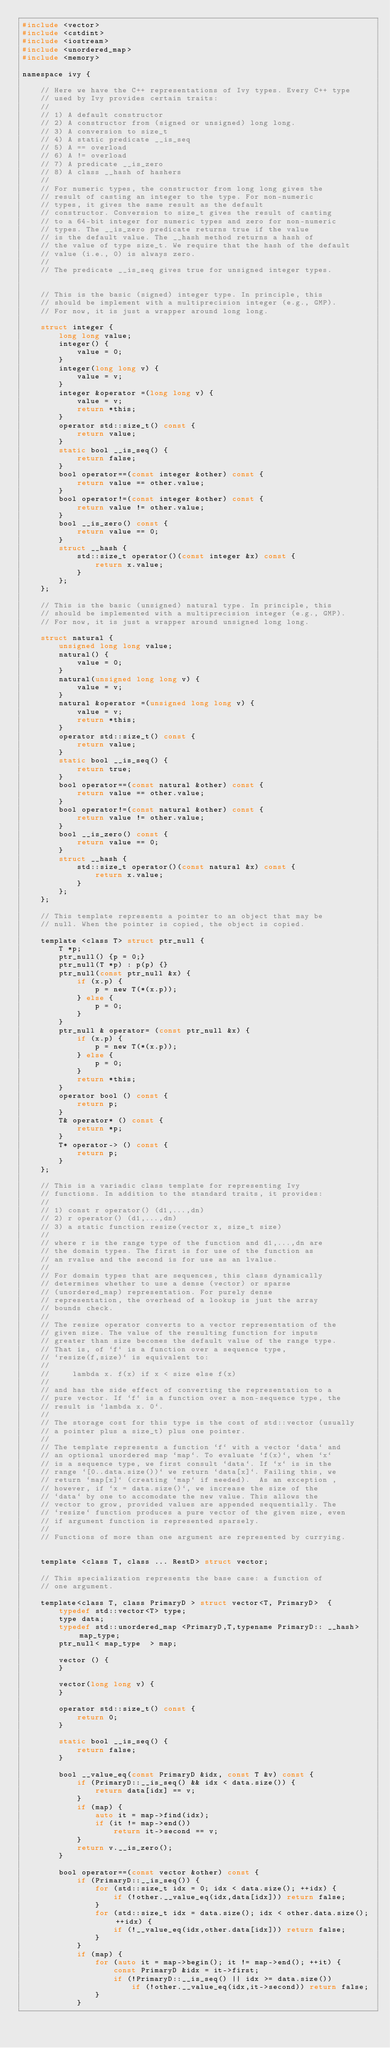<code> <loc_0><loc_0><loc_500><loc_500><_C_>#include <vector>
#include <cstdint>
#include <iostream>
#include <unordered_map>
#include <memory>

namespace ivy {

    // Here we have the C++ representations of Ivy types. Every C++ type
    // used by Ivy provides certain traits:
    //
    // 1) A default constructor
    // 2) A constructor from (signed or unsigned) long long.
    // 3) A conversion to size_t
    // 4) A static predicate __is_seq
    // 5) A == overload
    // 6) A != overload
    // 7) A predicate __is_zero
    // 8) A class __hash of hashers
    //
    // For numeric types, the constructor from long long gives the
    // result of casting an integer to the type. For non-numeric
    // types, it gives the same result as the default
    // constructor. Conversion to size_t gives the result of casting
    // to a 64-bit integer for numeric types and zero for non-numeric
    // types. The __is_zero predicate returns true if the value
    // is the default value. The __hash method returns a hash of
    // the value of type size_t. We require that the hash of the default
    // value (i.e., 0) is always zero.
    // 
    // The predicate __is_seq gives true for unsigned integer types.
    

    // This is the basic (signed) integer type. In principle, this
    // should be implement with a multiprecision integer (e.g., GMP).
    // For now, it is just a wrapper around long long.

    struct integer {
        long long value;
        integer() {
            value = 0;
        }
        integer(long long v) {
            value = v;
        }
        integer &operator =(long long v) {
            value = v;
            return *this;
        }
        operator std::size_t() const {
            return value;
        }
        static bool __is_seq() {
            return false;
        }
        bool operator==(const integer &other) const {
            return value == other.value;
        }
        bool operator!=(const integer &other) const {
            return value != other.value;
        }
        bool __is_zero() const {
            return value == 0;
        }
        struct __hash {
            std::size_t operator()(const integer &x) const {
                return x.value;
            }
        };
    };

    // This is the basic (unsigned) natural type. In principle, this
    // should be implemented with a multiprecision integer (e.g., GMP).
    // For now, it is just a wrapper around unsigned long long.

    struct natural {
        unsigned long long value;
        natural() {
            value = 0;
        }
        natural(unsigned long long v) {
            value = v;
        }
        natural &operator =(unsigned long long v) {
            value = v;
            return *this;
        }
        operator std::size_t() const {
            return value;
        }
        static bool __is_seq() {
            return true;
        }
        bool operator==(const natural &other) const {
            return value == other.value;
        }
        bool operator!=(const natural &other) const {
            return value != other.value;
        }
        bool __is_zero() const {
            return value == 0;
        }
        struct __hash {
            std::size_t operator()(const natural &x) const {
                return x.value;
            }
        };
    };

    // This template represents a pointer to an object that may be
    // null. When the pointer is copied, the object is copied.

    template <class T> struct ptr_null {
        T *p;
        ptr_null() {p = 0;}
        ptr_null(T *p) : p(p) {}
        ptr_null(const ptr_null &x) {
            if (x.p) {
                p = new T(*(x.p));
            } else {
                p = 0;
            }
        }
        ptr_null & operator= (const ptr_null &x) {
            if (x.p) {
                p = new T(*(x.p));
            } else {
                p = 0;
            }
            return *this;
        }
        operator bool () const {
            return p;
        }
        T& operator* () const {
            return *p;
        }
        T* operator-> () const {
            return p;
        }
    };

    // This is a variadic class template for representing Ivy
    // functions. In addition to the standard traits, it provides:
    //
    // 1) const r operator() (d1,...,dn)
    // 2) r operator() (d1,...,dn)
    // 3) a static function resize(vector x, size_t size)
    //
    // where r is the range type of the function and d1,...,dn are
    // the domain types. The first is for use of the function as
    // an rvalue and the second is for use as an lvalue.
    //
    // For domain types that are sequences, this class dynamically
    // determines whether to use a dense (vector) or sparse
    // (unordered_map) representation. For purely dense
    // representation, the overhead of a lookup is just the array
    // bounds check.
    //
    // The resize operator converts to a vector representation of the
    // given size. The value of the resulting function for inputs
    // greater than size becomes the default value of the range type.
    // That is, of `f` is a function over a sequence type,
    // `resize(f,size)` is equivalent to:
    //
    //     lambda x. f(x) if x < size else f(x)
    //
    // and has the side effect of converting the representation to a
    // pure vector. If `f` is a function over a non-sequence type, the
    // result is `lambda x. 0`.
    //
    // The storage cost for this type is the cost of std::vector (usually
    // a pointer plus a size_t) plus one pointer.
    //
    // The template represents a function `f` with a vector `data` and
    // an optional unordered map `map`. To evaluate `f(x)`, when `x`
    // is a sequence type, we first consult `data`. If `x` is in the
    // range `[0..data.size())` we return `data[x]`. Failing this, we
    // return `map[x]` (creating `map` if needed).  As an exception ,
    // however, if `x = data.size()`, we increase the size of the
    // `data` by one to accomodate the new value. This allows the
    // vector to grow, provided values are appended sequentially. The
    // `resize` function produces a pure vector of the given size, even
    // if argument function is represented sparsely. 
    //
    // Functions of more than one argument are represented by currying.
    
    
    template <class T, class ... RestD> struct vector;
    
    // This specialization represents the base case: a function of
    // one argument.

    template<class T, class PrimaryD > struct vector<T, PrimaryD>  {
        typedef std::vector<T> type;
        type data;
        typedef std::unordered_map <PrimaryD,T,typename PrimaryD:: __hash> map_type;
        ptr_null< map_type  > map;

        vector () {
        }

        vector(long long v) {
        }

        operator std::size_t() const {
            return 0;
        }

        static bool __is_seq() {
            return false;
        }

        bool __value_eq(const PrimaryD &idx, const T &v) const {
            if (PrimaryD::__is_seq() && idx < data.size()) {
                return data[idx] == v;
            }
            if (map) {
                auto it = map->find(idx);
                if (it != map->end())
                    return it->second == v;
            }
            return v.__is_zero();
        }
        
        bool operator==(const vector &other) const {
            if (PrimaryD::__is_seq()) {
                for (std::size_t idx = 0; idx < data.size(); ++idx) {
                    if (!other.__value_eq(idx,data[idx])) return false;
                }
                for (std::size_t idx = data.size(); idx < other.data.size(); ++idx) {
                    if (!__value_eq(idx,other.data[idx])) return false;
                }
            }
            if (map) {
                for (auto it = map->begin(); it != map->end(); ++it) {
                    const PrimaryD &idx = it->first;
                    if (!PrimaryD::__is_seq() || idx >= data.size())
                        if (!other.__value_eq(idx,it->second)) return false;
                }
            }</code> 